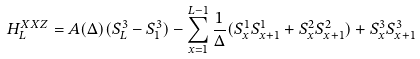Convert formula to latex. <formula><loc_0><loc_0><loc_500><loc_500>H ^ { X X Z } _ { L } = A ( \Delta ) ( S _ { L } ^ { 3 } - S _ { 1 } ^ { 3 } ) - \sum _ { x = 1 } ^ { L - 1 } \frac { 1 } { \Delta } ( S ^ { 1 } _ { x } S ^ { 1 } _ { x + 1 } + S ^ { 2 } _ { x } S ^ { 2 } _ { x + 1 } ) + S ^ { 3 } _ { x } S ^ { 3 } _ { x + 1 }</formula> 